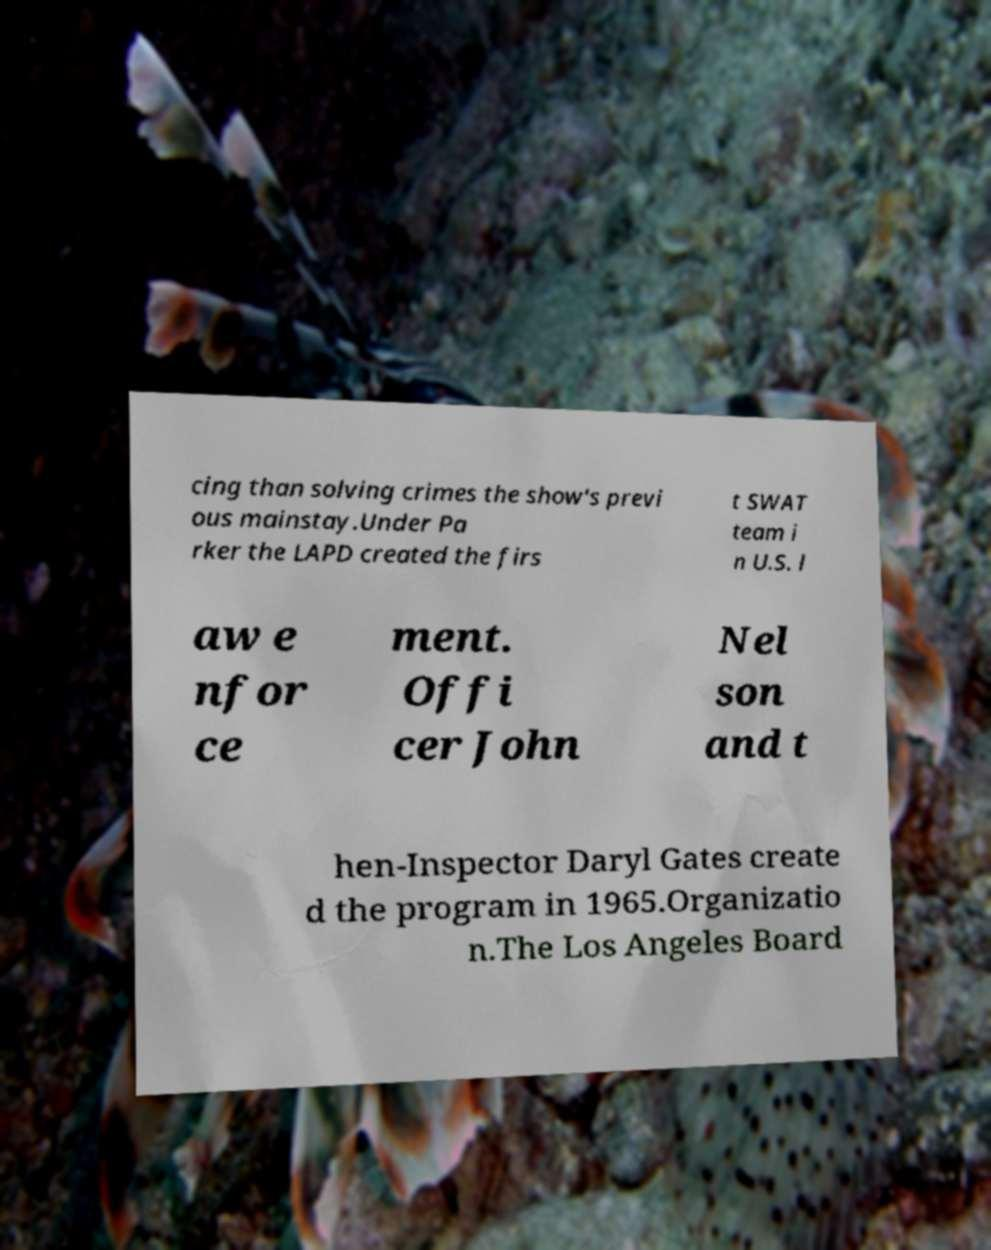Please identify and transcribe the text found in this image. cing than solving crimes the show's previ ous mainstay.Under Pa rker the LAPD created the firs t SWAT team i n U.S. l aw e nfor ce ment. Offi cer John Nel son and t hen-Inspector Daryl Gates create d the program in 1965.Organizatio n.The Los Angeles Board 